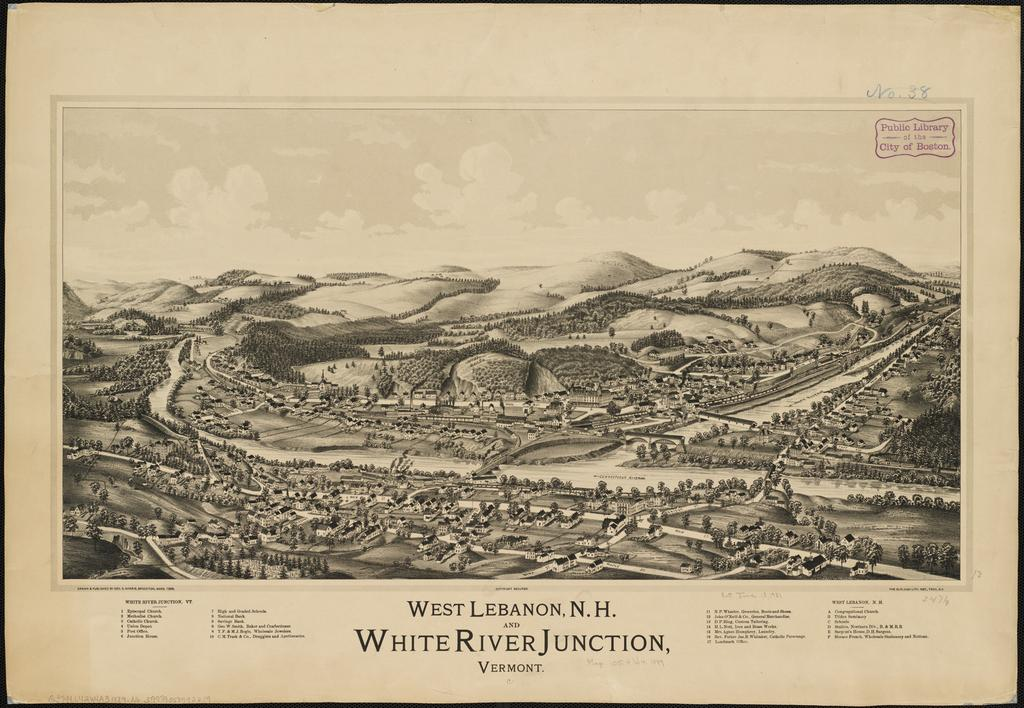<image>
Describe the image concisely. A drawing of a valley that says West Lebanon, N.H. White River Junction. 